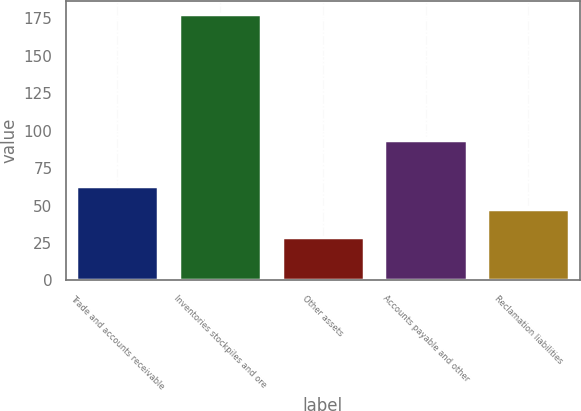Convert chart. <chart><loc_0><loc_0><loc_500><loc_500><bar_chart><fcel>Trade and accounts receivable<fcel>Inventories stockpiles and ore<fcel>Other assets<fcel>Accounts payable and other<fcel>Reclamation liabilities<nl><fcel>62.9<fcel>178<fcel>29<fcel>94<fcel>48<nl></chart> 